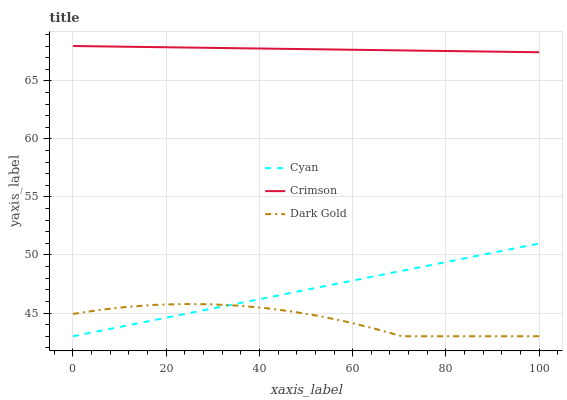Does Dark Gold have the minimum area under the curve?
Answer yes or no. Yes. Does Crimson have the maximum area under the curve?
Answer yes or no. Yes. Does Cyan have the minimum area under the curve?
Answer yes or no. No. Does Cyan have the maximum area under the curve?
Answer yes or no. No. Is Cyan the smoothest?
Answer yes or no. Yes. Is Dark Gold the roughest?
Answer yes or no. Yes. Is Dark Gold the smoothest?
Answer yes or no. No. Is Cyan the roughest?
Answer yes or no. No. Does Cyan have the lowest value?
Answer yes or no. Yes. Does Crimson have the highest value?
Answer yes or no. Yes. Does Cyan have the highest value?
Answer yes or no. No. Is Dark Gold less than Crimson?
Answer yes or no. Yes. Is Crimson greater than Dark Gold?
Answer yes or no. Yes. Does Dark Gold intersect Cyan?
Answer yes or no. Yes. Is Dark Gold less than Cyan?
Answer yes or no. No. Is Dark Gold greater than Cyan?
Answer yes or no. No. Does Dark Gold intersect Crimson?
Answer yes or no. No. 